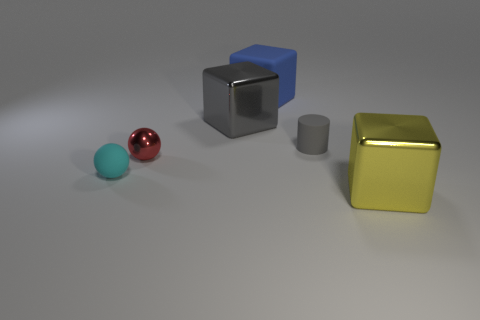Does the small red ball have the same material as the blue object?
Your response must be concise. No. There is a small rubber object that is in front of the matte cylinder; what shape is it?
Offer a terse response. Sphere. There is a big metal block behind the cyan matte thing; is it the same color as the tiny rubber cylinder?
Make the answer very short. Yes. Is the size of the sphere that is behind the rubber ball the same as the cyan ball?
Your response must be concise. Yes. Are there any big things of the same color as the matte cylinder?
Keep it short and to the point. Yes. Are there any large things that are to the left of the metal object that is to the right of the big matte thing?
Give a very brief answer. Yes. Are there any other big blocks that have the same material as the large gray block?
Offer a very short reply. Yes. What is the large block that is behind the big metal object on the left side of the big yellow metal cube made of?
Your response must be concise. Rubber. There is a thing that is in front of the small red shiny object and left of the small gray matte cylinder; what is its material?
Your response must be concise. Rubber. Are there the same number of cyan matte spheres behind the tiny red shiny object and tiny yellow matte spheres?
Offer a very short reply. Yes. 